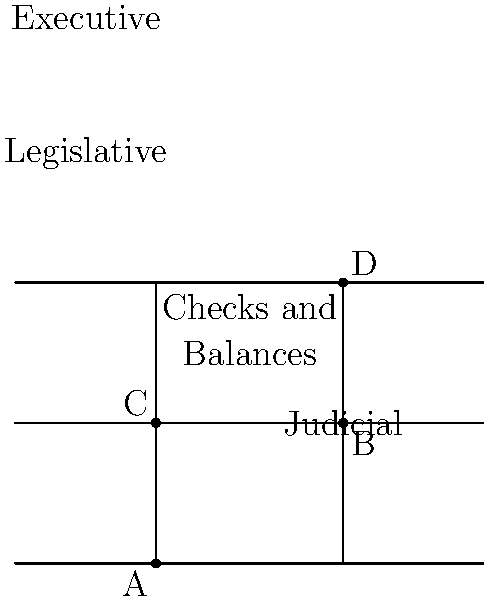In the diagram representing the separation of powers in government, parallel lines represent the three branches of government, while transversals represent the system of checks and balances. If angle BAC measures 60°, what is the measure of angle BCD? To solve this problem, we'll use the properties of parallel lines and transversals:

1. In the diagram, the three horizontal lines represent the Executive, Legislative, and Judicial branches of government.

2. The two transversal lines represent the system of checks and balances between these branches.

3. When parallel lines are cut by a transversal, corresponding angles are congruent.

4. Angle BAC and angle BCD are corresponding angles because:
   - They are on the same side of the transversal
   - One angle is an exterior angle of the parallel lines, and the other is an interior angle on the same side of the transversal

5. Given that angle BAC measures 60°, we can conclude that angle BCD must also measure 60° due to the corresponding angles theorem.

This geometric representation illustrates how the checks and balances system ensures that no single branch of government becomes too powerful, maintaining a balance similar to the equal corresponding angles in the parallel line system.
Answer: 60° 